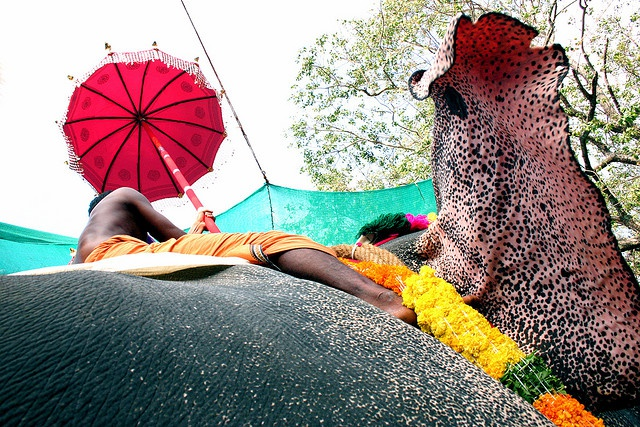Describe the objects in this image and their specific colors. I can see elephant in white, black, gray, teal, and darkgray tones, umbrella in white, red, brown, and black tones, and people in white, khaki, gray, black, and darkgray tones in this image. 